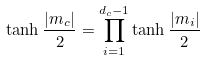<formula> <loc_0><loc_0><loc_500><loc_500>\tanh \frac { | m _ { c } | } { 2 } = \prod _ { i = 1 } ^ { d _ { c } - 1 } \tanh \frac { | m _ { i } | } { 2 }</formula> 